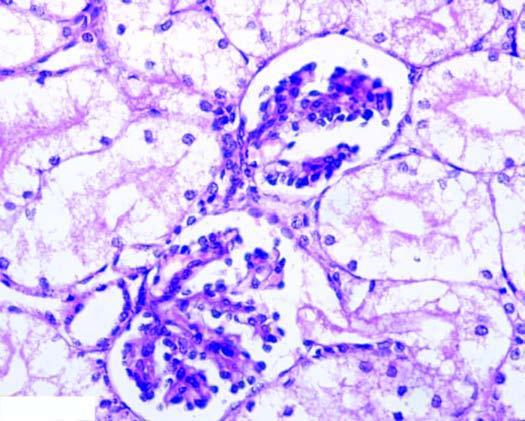re the nuclei of affected tubules pale?
Answer the question using a single word or phrase. Yes 